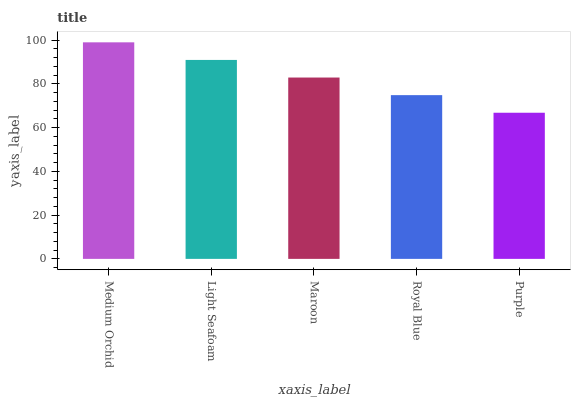Is Purple the minimum?
Answer yes or no. Yes. Is Medium Orchid the maximum?
Answer yes or no. Yes. Is Light Seafoam the minimum?
Answer yes or no. No. Is Light Seafoam the maximum?
Answer yes or no. No. Is Medium Orchid greater than Light Seafoam?
Answer yes or no. Yes. Is Light Seafoam less than Medium Orchid?
Answer yes or no. Yes. Is Light Seafoam greater than Medium Orchid?
Answer yes or no. No. Is Medium Orchid less than Light Seafoam?
Answer yes or no. No. Is Maroon the high median?
Answer yes or no. Yes. Is Maroon the low median?
Answer yes or no. Yes. Is Light Seafoam the high median?
Answer yes or no. No. Is Purple the low median?
Answer yes or no. No. 